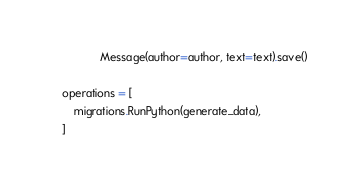<code> <loc_0><loc_0><loc_500><loc_500><_Python_>                Message(author=author, text=text).save()

    operations = [
        migrations.RunPython(generate_data),
    ]
</code> 